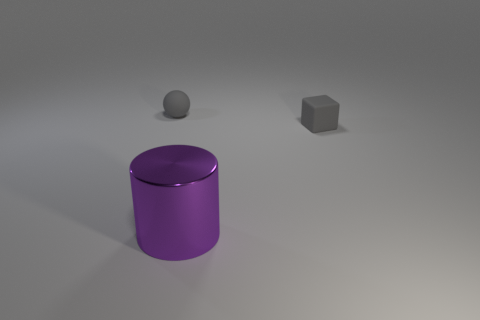Add 2 gray matte blocks. How many objects exist? 5 Subtract all cylinders. How many objects are left? 2 Add 3 small matte balls. How many small matte balls exist? 4 Subtract 0 green cylinders. How many objects are left? 3 Subtract all small yellow cylinders. Subtract all gray blocks. How many objects are left? 2 Add 3 tiny gray objects. How many tiny gray objects are left? 5 